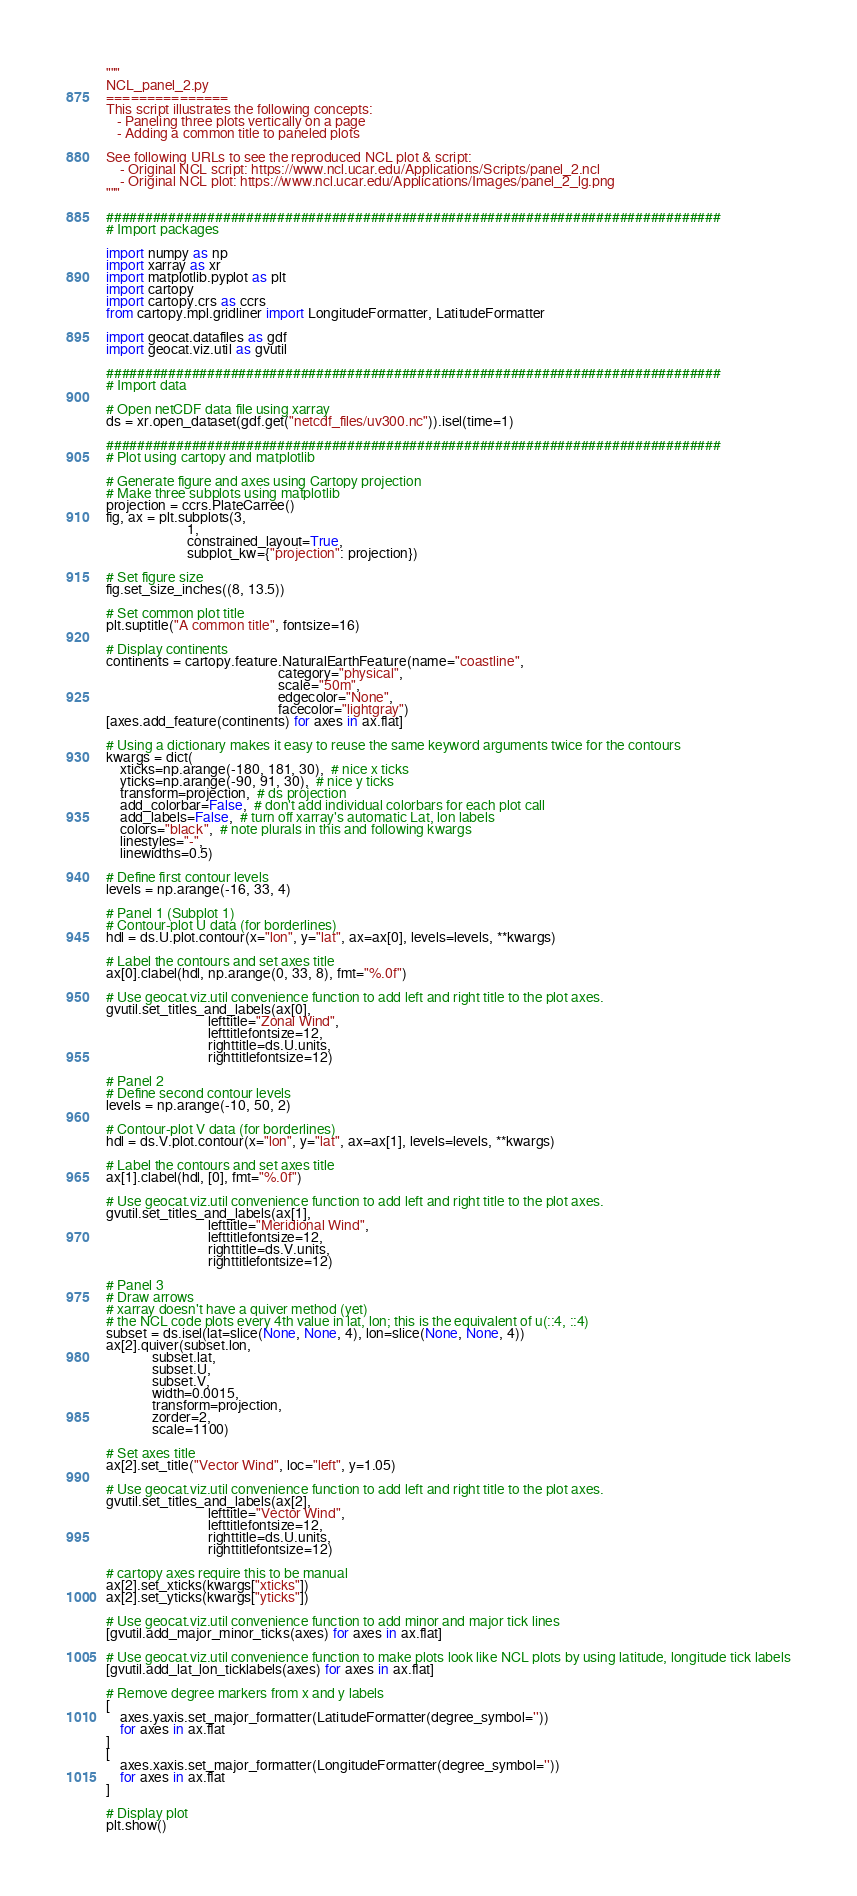Convert code to text. <code><loc_0><loc_0><loc_500><loc_500><_Python_>"""
NCL_panel_2.py
===============
This script illustrates the following concepts:
   - Paneling three plots vertically on a page
   - Adding a common title to paneled plots

See following URLs to see the reproduced NCL plot & script:
    - Original NCL script: https://www.ncl.ucar.edu/Applications/Scripts/panel_2.ncl
    - Original NCL plot: https://www.ncl.ucar.edu/Applications/Images/panel_2_lg.png
"""

###############################################################################
# Import packages

import numpy as np
import xarray as xr
import matplotlib.pyplot as plt
import cartopy
import cartopy.crs as ccrs
from cartopy.mpl.gridliner import LongitudeFormatter, LatitudeFormatter

import geocat.datafiles as gdf
import geocat.viz.util as gvutil

###############################################################################
# Import data

# Open netCDF data file using xarray
ds = xr.open_dataset(gdf.get("netcdf_files/uv300.nc")).isel(time=1)

###############################################################################
# Plot using cartopy and matplotlib

# Generate figure and axes using Cartopy projection
# Make three subplots using matplotlib
projection = ccrs.PlateCarree()
fig, ax = plt.subplots(3,
                       1,
                       constrained_layout=True,
                       subplot_kw={"projection": projection})

# Set figure size
fig.set_size_inches((8, 13.5))

# Set common plot title
plt.suptitle("A common title", fontsize=16)

# Display continents
continents = cartopy.feature.NaturalEarthFeature(name="coastline",
                                                 category="physical",
                                                 scale="50m",
                                                 edgecolor="None",
                                                 facecolor="lightgray")
[axes.add_feature(continents) for axes in ax.flat]

# Using a dictionary makes it easy to reuse the same keyword arguments twice for the contours
kwargs = dict(
    xticks=np.arange(-180, 181, 30),  # nice x ticks
    yticks=np.arange(-90, 91, 30),  # nice y ticks
    transform=projection,  # ds projection
    add_colorbar=False,  # don't add individual colorbars for each plot call
    add_labels=False,  # turn off xarray's automatic Lat, lon labels
    colors="black",  # note plurals in this and following kwargs
    linestyles="-",
    linewidths=0.5)

# Define first contour levels
levels = np.arange(-16, 33, 4)

# Panel 1 (Subplot 1)
# Contour-plot U data (for borderlines)
hdl = ds.U.plot.contour(x="lon", y="lat", ax=ax[0], levels=levels, **kwargs)

# Label the contours and set axes title
ax[0].clabel(hdl, np.arange(0, 33, 8), fmt="%.0f")

# Use geocat.viz.util convenience function to add left and right title to the plot axes.
gvutil.set_titles_and_labels(ax[0],
                             lefttitle="Zonal Wind",
                             lefttitlefontsize=12,
                             righttitle=ds.U.units,
                             righttitlefontsize=12)

# Panel 2
# Define second contour levels
levels = np.arange(-10, 50, 2)

# Contour-plot V data (for borderlines)
hdl = ds.V.plot.contour(x="lon", y="lat", ax=ax[1], levels=levels, **kwargs)

# Label the contours and set axes title
ax[1].clabel(hdl, [0], fmt="%.0f")

# Use geocat.viz.util convenience function to add left and right title to the plot axes.
gvutil.set_titles_and_labels(ax[1],
                             lefttitle="Meridional Wind",
                             lefttitlefontsize=12,
                             righttitle=ds.V.units,
                             righttitlefontsize=12)

# Panel 3
# Draw arrows
# xarray doesn't have a quiver method (yet)
# the NCL code plots every 4th value in lat, lon; this is the equivalent of u(::4, ::4)
subset = ds.isel(lat=slice(None, None, 4), lon=slice(None, None, 4))
ax[2].quiver(subset.lon,
             subset.lat,
             subset.U,
             subset.V,
             width=0.0015,
             transform=projection,
             zorder=2,
             scale=1100)

# Set axes title
ax[2].set_title("Vector Wind", loc="left", y=1.05)

# Use geocat.viz.util convenience function to add left and right title to the plot axes.
gvutil.set_titles_and_labels(ax[2],
                             lefttitle="Vector Wind",
                             lefttitlefontsize=12,
                             righttitle=ds.U.units,
                             righttitlefontsize=12)

# cartopy axes require this to be manual
ax[2].set_xticks(kwargs["xticks"])
ax[2].set_yticks(kwargs["yticks"])

# Use geocat.viz.util convenience function to add minor and major tick lines
[gvutil.add_major_minor_ticks(axes) for axes in ax.flat]

# Use geocat.viz.util convenience function to make plots look like NCL plots by using latitude, longitude tick labels
[gvutil.add_lat_lon_ticklabels(axes) for axes in ax.flat]

# Remove degree markers from x and y labels
[
    axes.yaxis.set_major_formatter(LatitudeFormatter(degree_symbol=''))
    for axes in ax.flat
]
[
    axes.xaxis.set_major_formatter(LongitudeFormatter(degree_symbol=''))
    for axes in ax.flat
]

# Display plot
plt.show()
</code> 